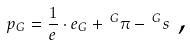Convert formula to latex. <formula><loc_0><loc_0><loc_500><loc_500>p _ { G } = \frac { 1 } { e } \cdot e _ { G } + \, ^ { G } \pi - \, ^ { G } s \text { ,}</formula> 